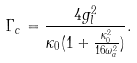Convert formula to latex. <formula><loc_0><loc_0><loc_500><loc_500>\Gamma _ { c } = \frac { 4 g _ { l } ^ { 2 } } { \kappa _ { 0 } ( 1 + \frac { \kappa _ { 0 } ^ { 2 } } { 1 6 \omega _ { a } ^ { 2 } } ) } .</formula> 